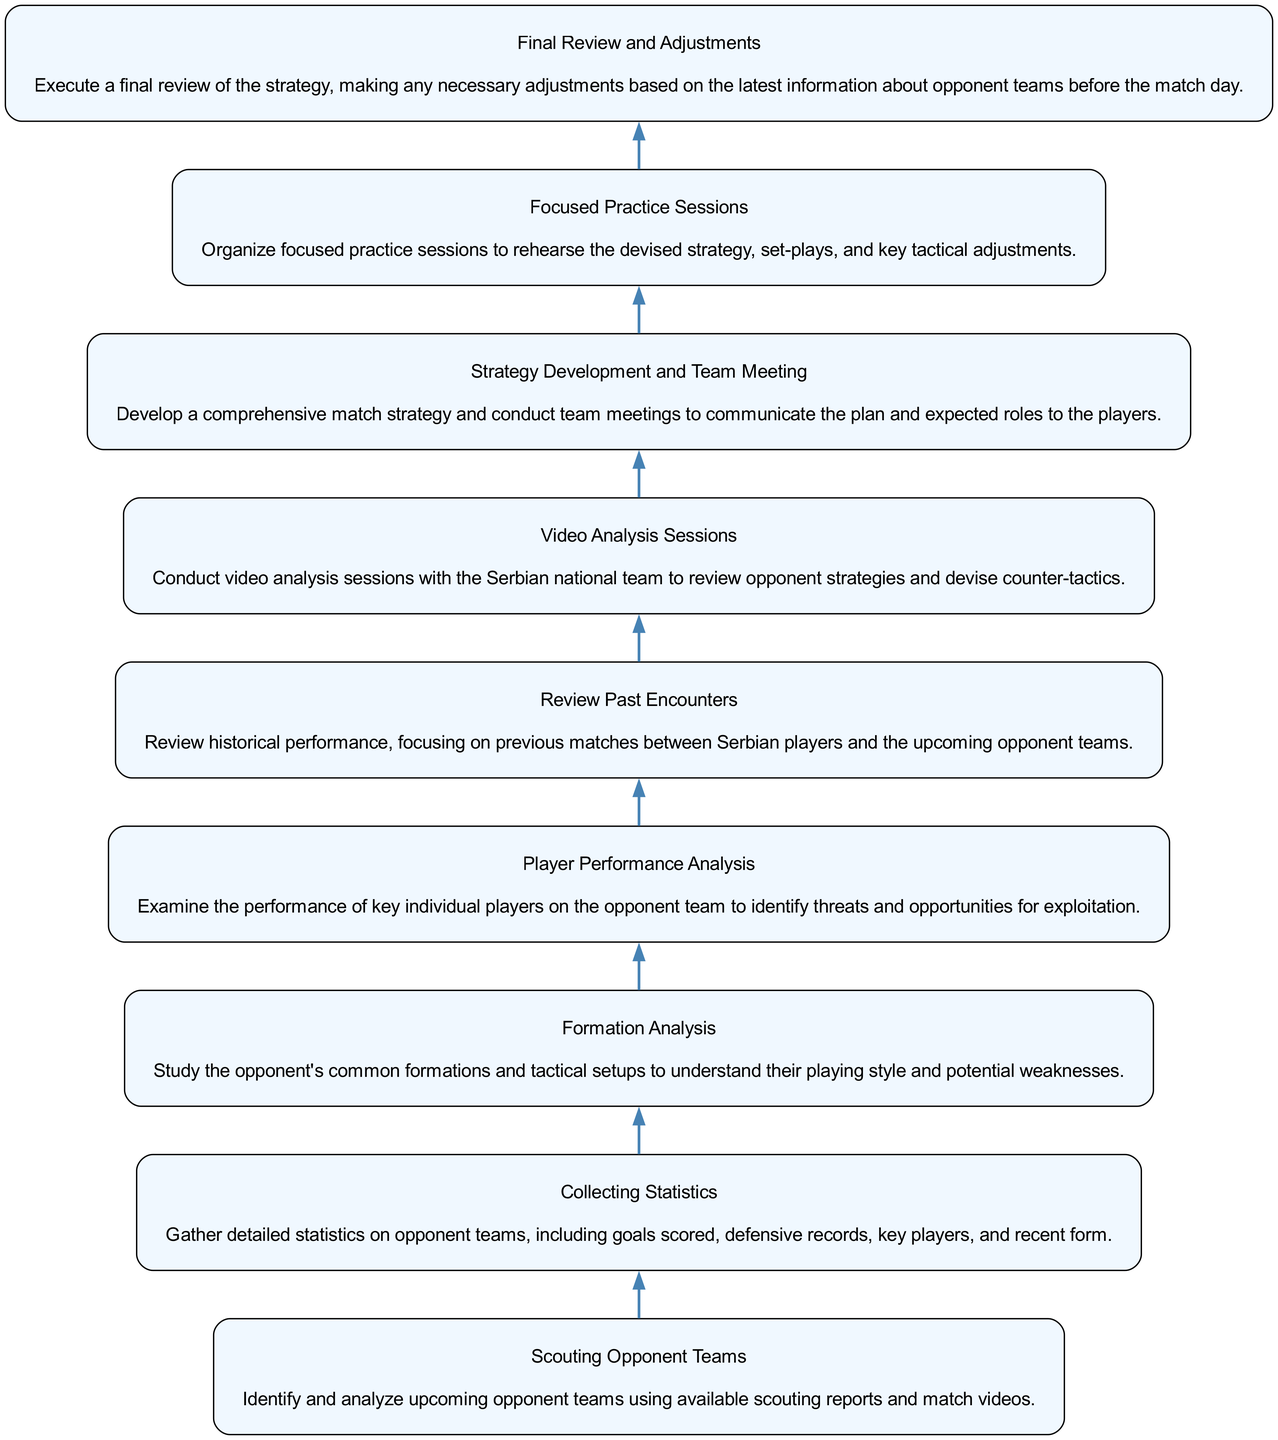What is the first step in the preparation and strategy flow? The diagram begins with "Scouting Opponent Teams," which is the first node in the flow. This indicates that the preparation process starts by identifying and analyzing upcoming opponents.
Answer: Scouting Opponent Teams How many nodes are present in the diagram? The diagram has a total of eight nodes, each representing a stage in the analysis process from scouting to final review.
Answer: Eight What is the last step before the final review? The final step before "Final Review and Adjustments" is "Focused Practice Sessions," as indicated in the flow sequence. This suggests that after practicing, a review is conducted.
Answer: Focused Practice Sessions What is analyzed for potential weaknesses in the opponent team? The "Formation Analysis" node focuses on studying the opponent's common formations and tactical setups, which helps identify their potential weaknesses.
Answer: Formations Which step comes after video analysis sessions? According to the flow, the step that follows "Video Analysis Sessions" is "Strategy Development and Team Meeting.” This indicates that after analyzing opponent strategies, the national team develops a match strategy.
Answer: Strategy Development and Team Meeting What two aspects does "Player Performance Analysis" focus on? "Player Performance Analysis" examines the performance of key individual players, identifying both threats and opportunities for exploitation against the opponent team.
Answer: Key players' performance and threats Which two nodes are directly connected? "Collecting Statistics" is directly connected to "Formation Analysis." This implies that collecting statistics leads to analyzing formations in the process of preparing for a match.
Answer: Collecting Statistics and Formation Analysis What is the purpose of the "Final Review and Adjustments"? The purpose of "Final Review and Adjustments" is to conduct a thorough review of the entire strategy and make any necessary changes based on the latest information available about the opponent teams.
Answer: Review strategy and adjustments 